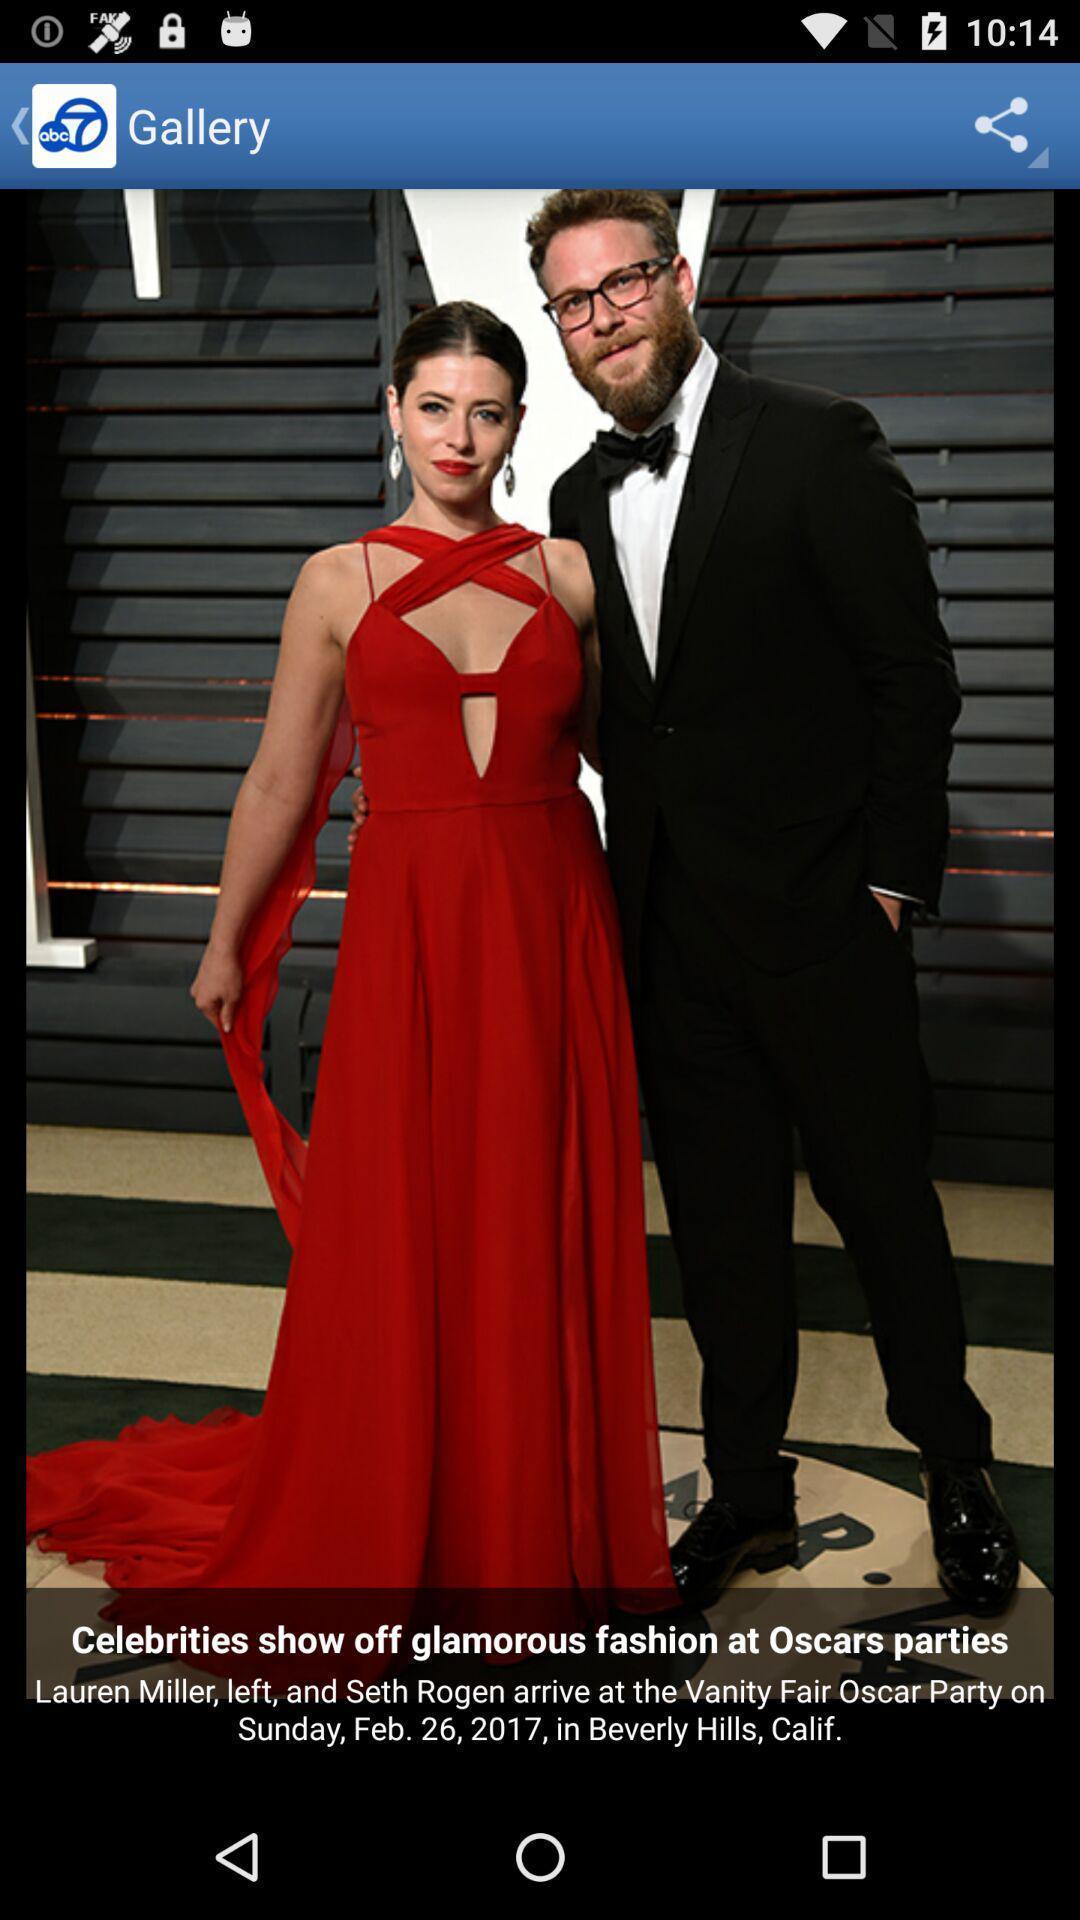Tell me what you see in this picture. Screen page of a gallery. 